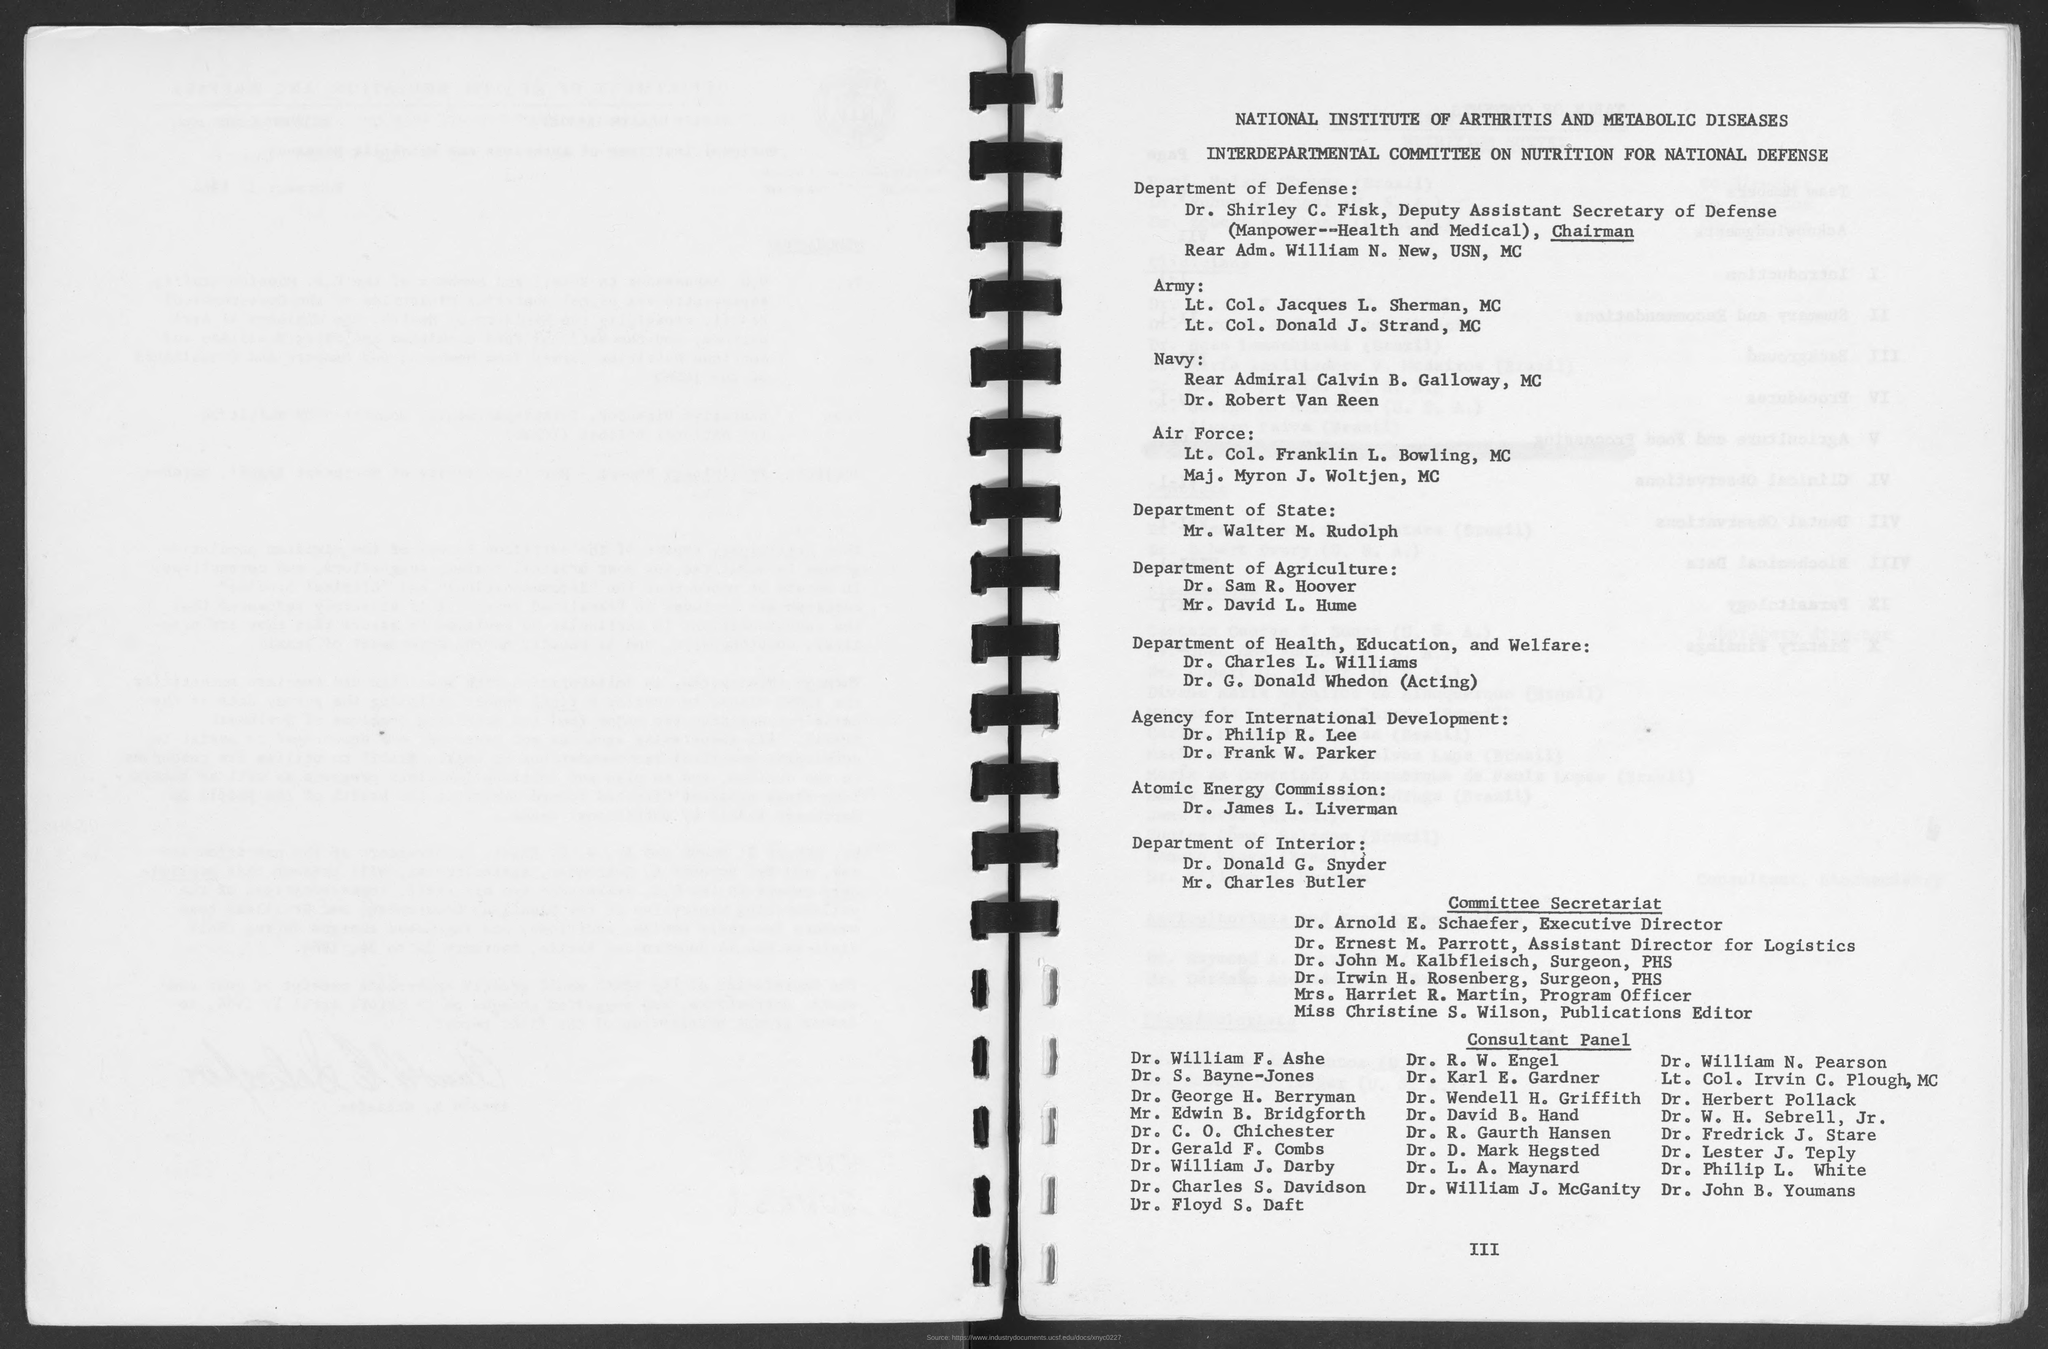Specify some key components in this picture. Mr. Walter M. Rudolph is a member of the Department of State, as stated in the provided page. Dr. Sam R. Hoover belongs to the Department of Agriculture, as mentioned in the given form. Mr. Charles Butler belongs to the Department of Interior. 